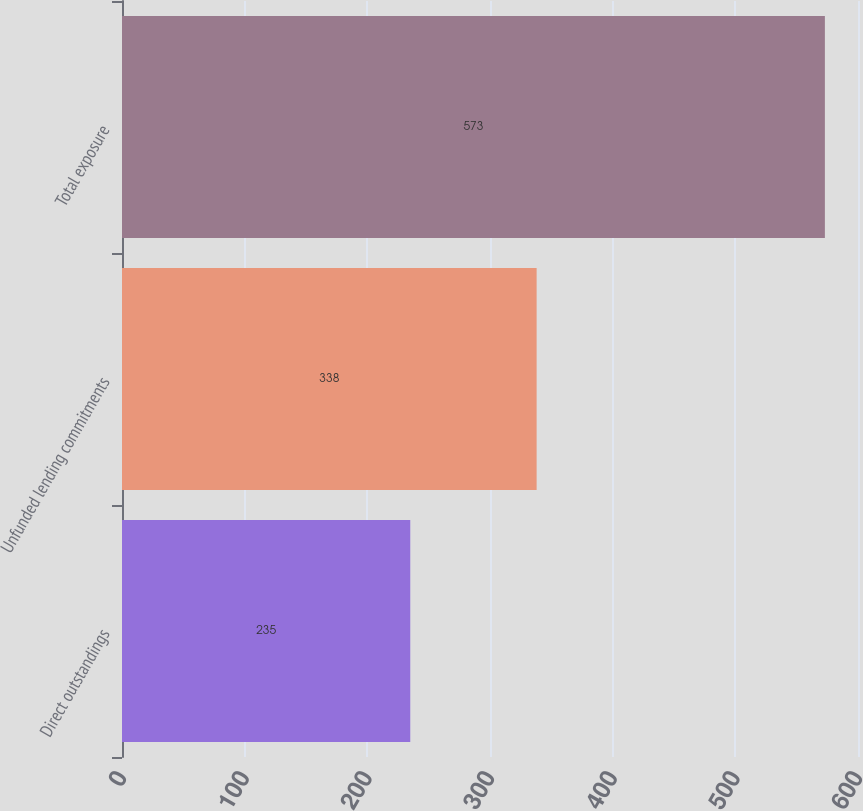Convert chart to OTSL. <chart><loc_0><loc_0><loc_500><loc_500><bar_chart><fcel>Direct outstandings<fcel>Unfunded lending commitments<fcel>Total exposure<nl><fcel>235<fcel>338<fcel>573<nl></chart> 